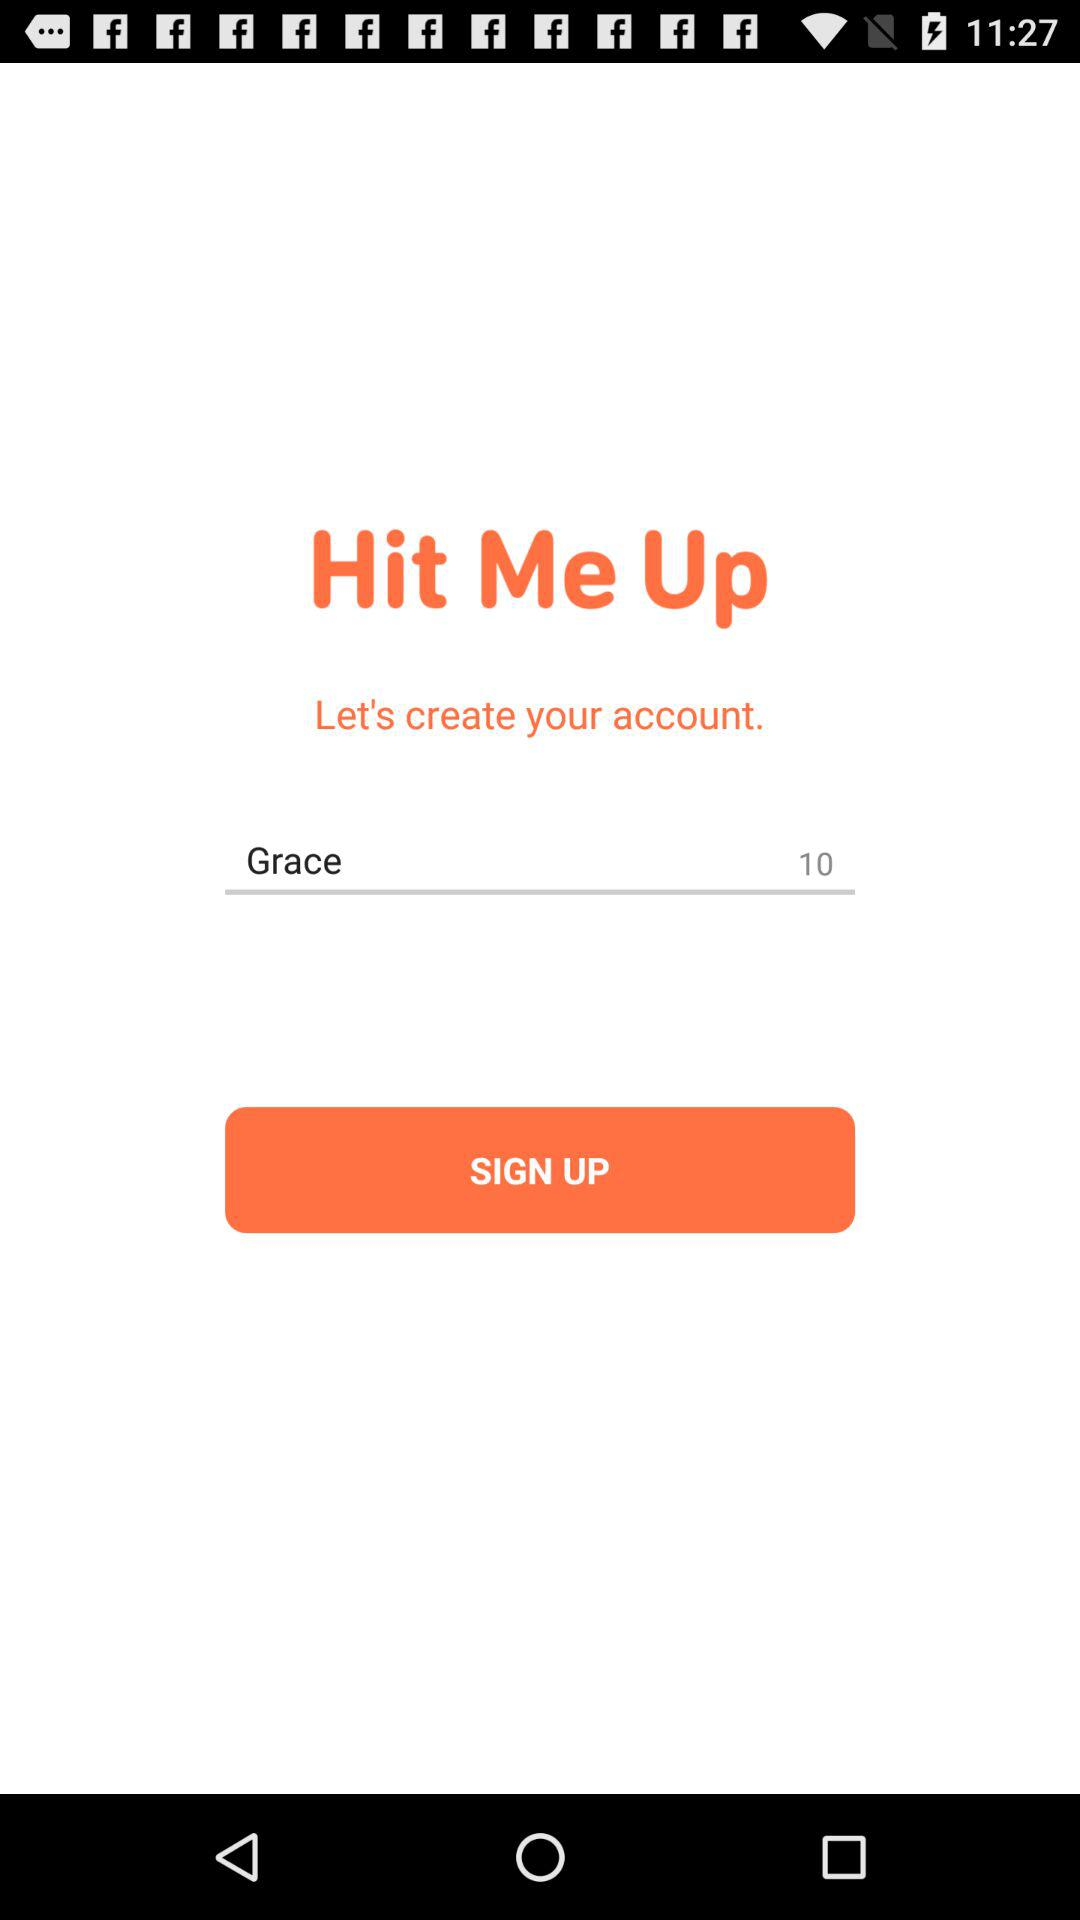What is the user name? The user name is Grace. 